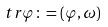<formula> <loc_0><loc_0><loc_500><loc_500>\ t r \varphi \colon = ( \varphi , \omega )</formula> 